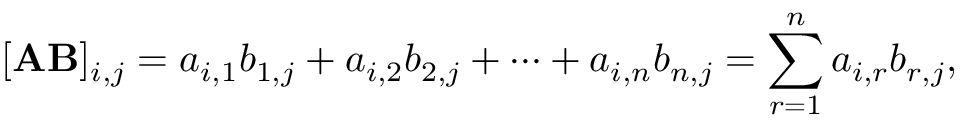<formula> <loc_0><loc_0><loc_500><loc_500>[ A B ] _ { i , j } = a _ { i , 1 } b _ { 1 , j } + a _ { i , 2 } b _ { 2 , j } + \cdots + a _ { i , n } b _ { n , j } = \sum _ { r = 1 } ^ { n } a _ { i , r } b _ { r , j } ,</formula> 